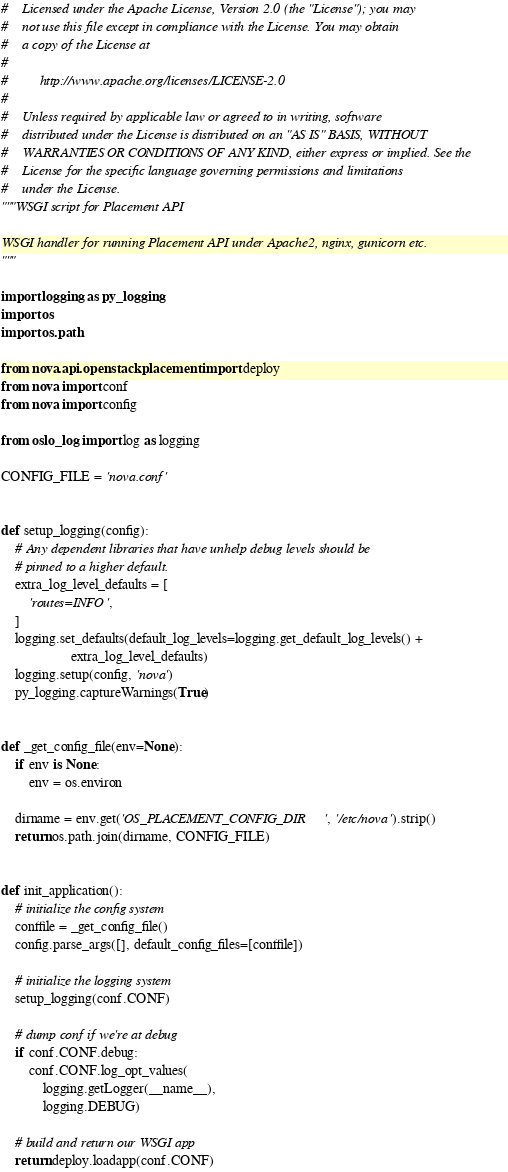Convert code to text. <code><loc_0><loc_0><loc_500><loc_500><_Python_>#    Licensed under the Apache License, Version 2.0 (the "License"); you may
#    not use this file except in compliance with the License. You may obtain
#    a copy of the License at
#
#         http://www.apache.org/licenses/LICENSE-2.0
#
#    Unless required by applicable law or agreed to in writing, software
#    distributed under the License is distributed on an "AS IS" BASIS, WITHOUT
#    WARRANTIES OR CONDITIONS OF ANY KIND, either express or implied. See the
#    License for the specific language governing permissions and limitations
#    under the License.
"""WSGI script for Placement API

WSGI handler for running Placement API under Apache2, nginx, gunicorn etc.
"""

import logging as py_logging
import os
import os.path

from nova.api.openstack.placement import deploy
from nova import conf
from nova import config

from oslo_log import log as logging

CONFIG_FILE = 'nova.conf'


def setup_logging(config):
    # Any dependent libraries that have unhelp debug levels should be
    # pinned to a higher default.
    extra_log_level_defaults = [
        'routes=INFO',
    ]
    logging.set_defaults(default_log_levels=logging.get_default_log_levels() +
                    extra_log_level_defaults)
    logging.setup(config, 'nova')
    py_logging.captureWarnings(True)


def _get_config_file(env=None):
    if env is None:
        env = os.environ

    dirname = env.get('OS_PLACEMENT_CONFIG_DIR', '/etc/nova').strip()
    return os.path.join(dirname, CONFIG_FILE)


def init_application():
    # initialize the config system
    conffile = _get_config_file()
    config.parse_args([], default_config_files=[conffile])

    # initialize the logging system
    setup_logging(conf.CONF)

    # dump conf if we're at debug
    if conf.CONF.debug:
        conf.CONF.log_opt_values(
            logging.getLogger(__name__),
            logging.DEBUG)

    # build and return our WSGI app
    return deploy.loadapp(conf.CONF)
</code> 